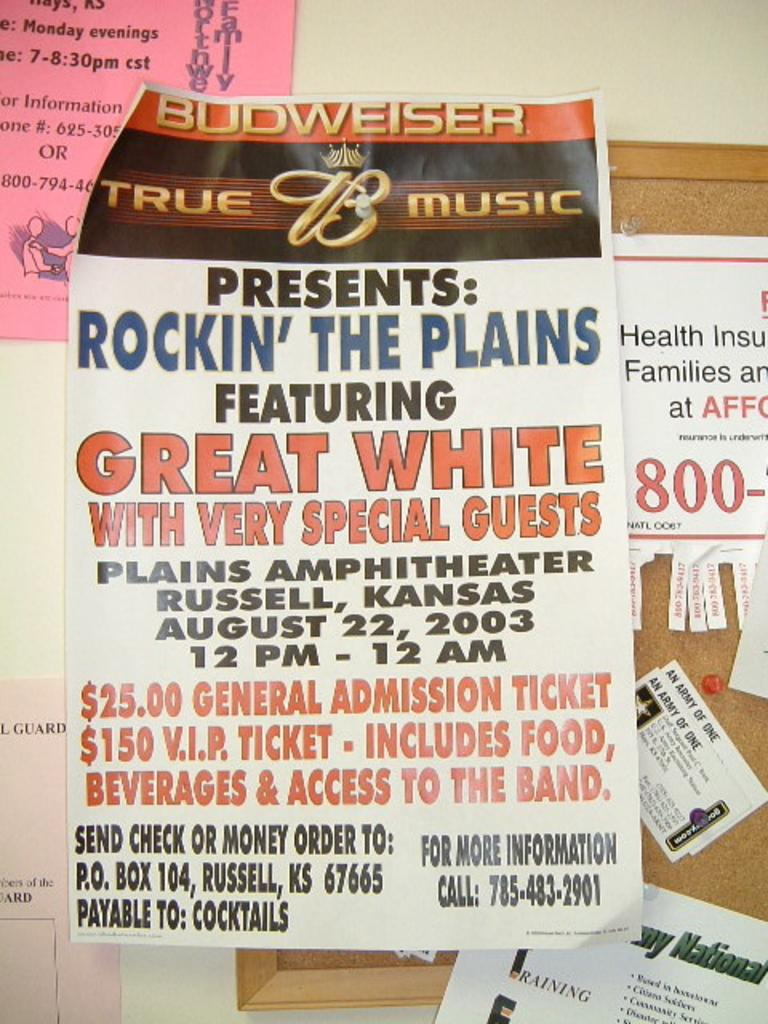<image>
Render a clear and concise summary of the photo. corkboard with several things attached to it including a budweiser sponsored rockin the plains event on august 22, 2003 